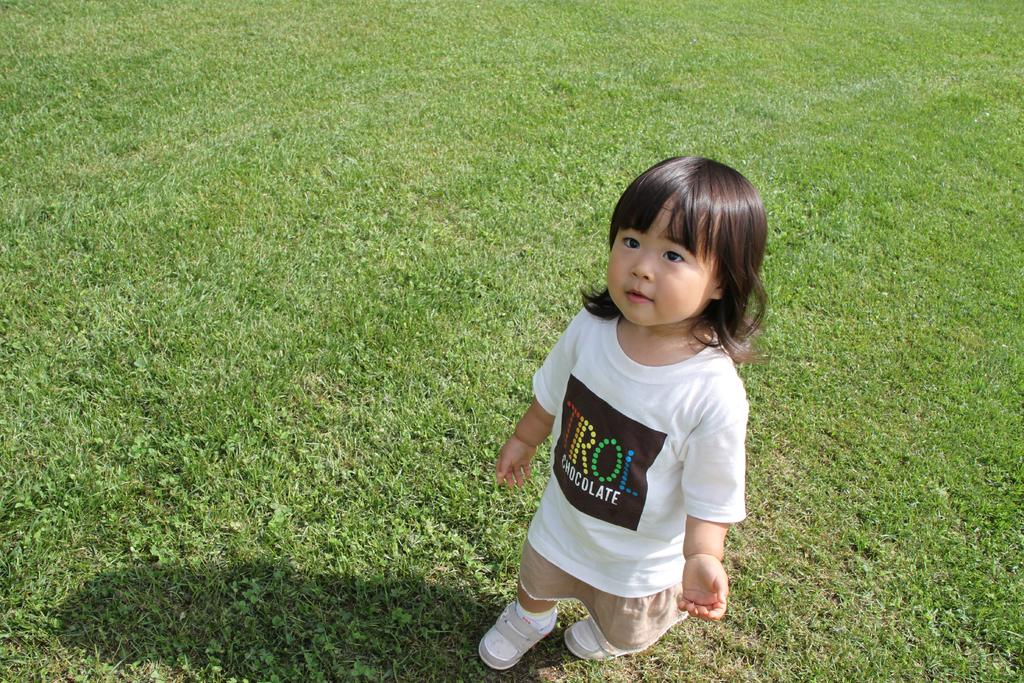Who is the main subject in the image? There is a little girl in the image. What is the girl wearing on her upper body? The girl is wearing a white t-shirt. What type of footwear is the girl wearing? The girl is wearing shoes. What type of terrain is the girl standing on? The girl is standing on grassland. What type of wilderness is the girl exploring in the image? There is no wilderness present in the image; the girl is standing on grassland. How does the girl twist her body in the image? The image does not show the girl twisting her body; she is standing still. 